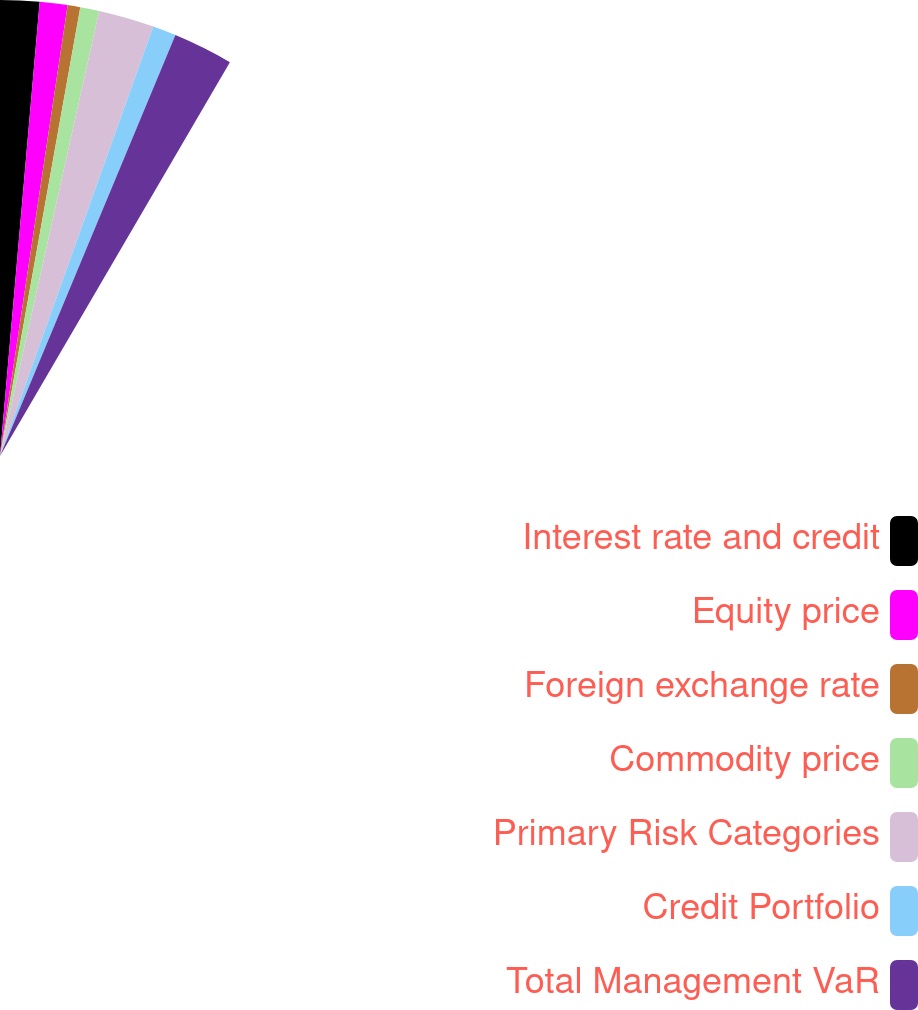<chart> <loc_0><loc_0><loc_500><loc_500><pie_chart><fcel>Interest rate and credit<fcel>Equity price<fcel>Foreign exchange rate<fcel>Commodity price<fcel>Primary Risk Categories<fcel>Credit Portfolio<fcel>Total Management VaR<nl><fcel>16.49%<fcel>11.7%<fcel>5.32%<fcel>7.98%<fcel>23.4%<fcel>9.84%<fcel>25.27%<nl></chart> 